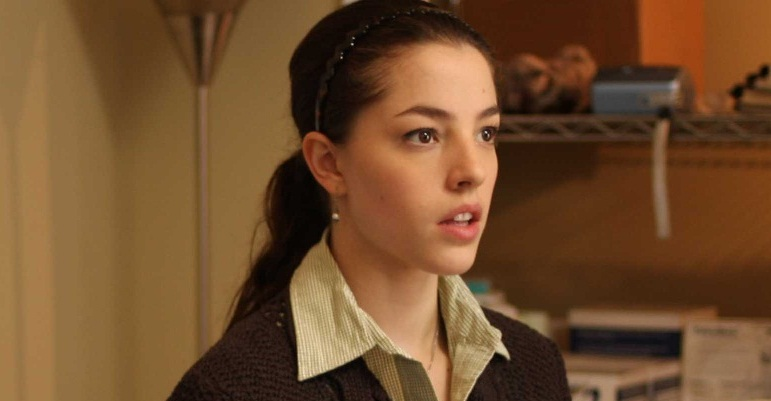Describe a very realistic scenario where this image might have been taken. Provide both a long and a short response. Long response: The image might have been taken in a small, cozy office or study, where the woman is working on a project that demands her full attention. She could be an independent writer or a researcher, deeply engrossed in her work. The softly lit room, filled with books and files, supports a quiet and focused atmosphere. Maybe she has just received an important email or finished reading a particularly thought-provoking article, hence the expression of deep contemplation. The subtle details in the background, such as the neatly arranged items on the shelf, indicate an organized and methodical approach to her work, hinting at a dedicated and thoughtful individual. Short response: The image was likely taken in a home office where the woman is reflecting on something she has just read. The serious expression on her face suggests she is deeply absorbed in thought, possibly considering her next steps or sorting through complex information. 